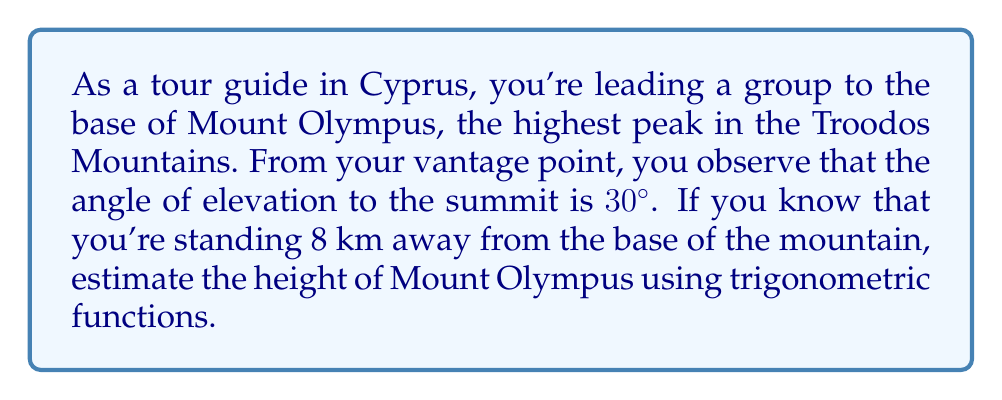What is the answer to this math problem? Let's approach this step-by-step:

1) First, let's visualize the problem:

[asy]
import geometry;

size(200);
pair A = (0,0), B = (8,0), C = (8,4.62);
draw(A--B--C--A);
label("A", A, SW);
label("B", B, SE);
label("C", C, NE);
label("8 km", (A+B)/2, S);
label("h", (B+C)/2, E);
label("30°", A, NW);
draw(A--A+(1,0), arrow=Arrow);
draw(A--A+(cos(pi/6),sin(pi/6)), arrow=Arrow);
[/asy]

2) In this right-angled triangle:
   - The adjacent side (AB) is 8 km
   - The angle of elevation is 30°
   - We need to find the opposite side (BC), which represents the height

3) We can use the tangent function, as it relates the opposite and adjacent sides:

   $$\tan \theta = \frac{\text{opposite}}{\text{adjacent}}$$

4) Substituting our known values:

   $$\tan 30° = \frac{h}{8}$$

5) We know that $\tan 30° = \frac{1}{\sqrt{3}}$, so:

   $$\frac{1}{\sqrt{3}} = \frac{h}{8}$$

6) Solving for h:

   $$h = 8 \cdot \frac{1}{\sqrt{3}}$$

7) Simplifying:

   $$h = \frac{8}{\sqrt{3}} \approx 4.62 \text{ km}$$

Therefore, the estimated height of Mount Olympus is approximately 4.62 km.
Answer: $4.62 \text{ km}$ 